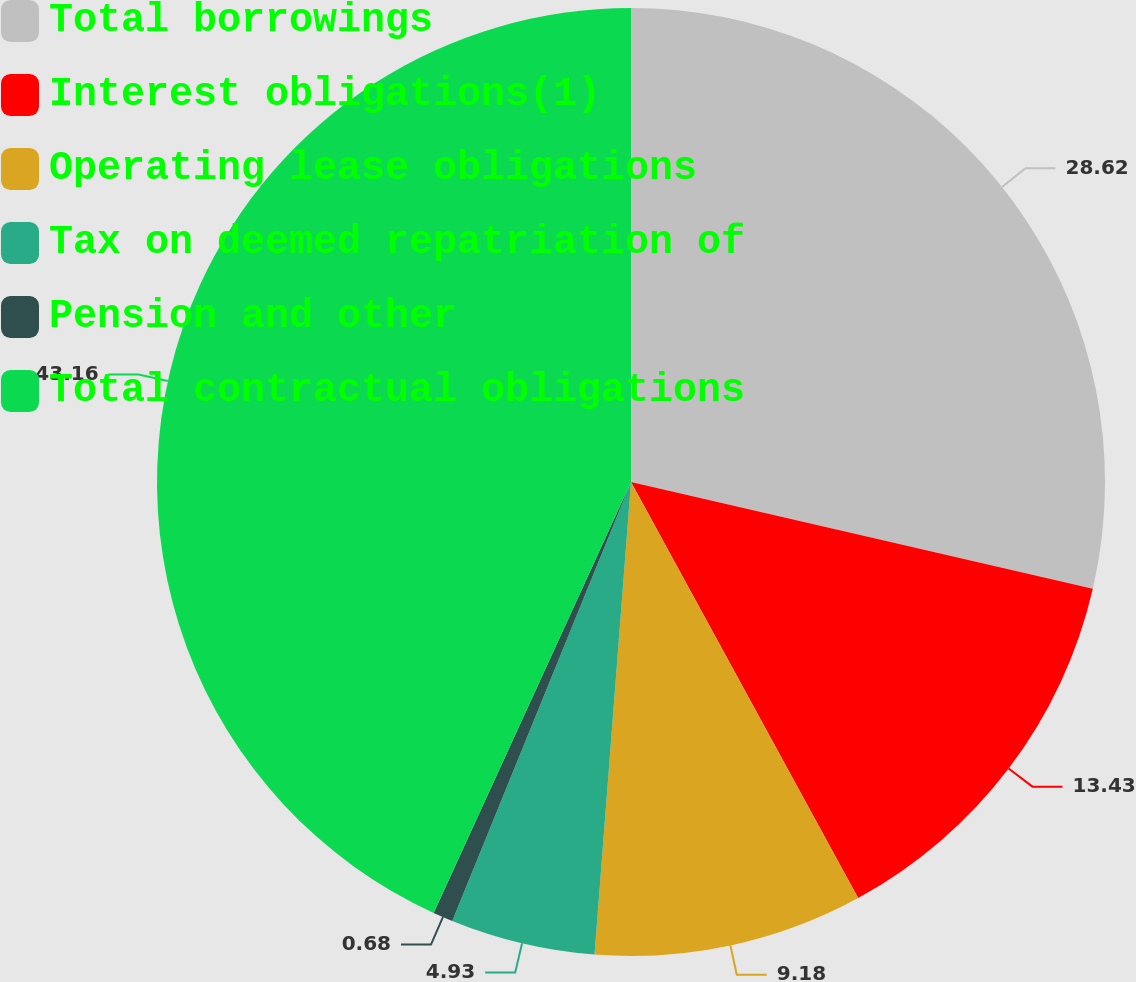<chart> <loc_0><loc_0><loc_500><loc_500><pie_chart><fcel>Total borrowings<fcel>Interest obligations(1)<fcel>Operating lease obligations<fcel>Tax on deemed repatriation of<fcel>Pension and other<fcel>Total contractual obligations<nl><fcel>28.62%<fcel>13.43%<fcel>9.18%<fcel>4.93%<fcel>0.68%<fcel>43.17%<nl></chart> 